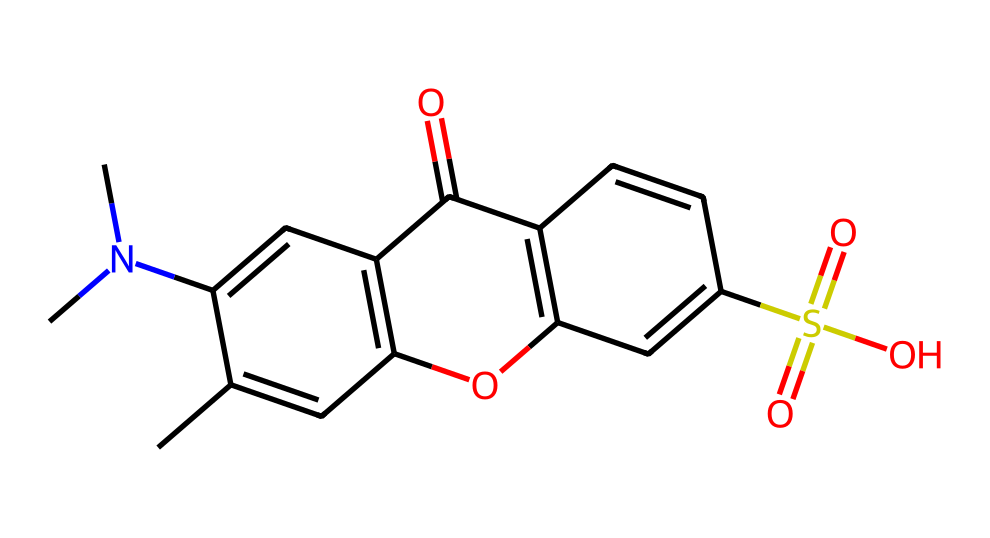What is the primary functional group present in this chemical? The chemical structure contains a sulfonic acid group (S(=O)(=O)O) indicated by the sulfur atom bonded to oxygen atoms and a hydroxyl group.
Answer: sulfonic acid How many nitrogen atoms are present in this chemical? Counting the nitrogen atoms in the structure reveals there is one nitrogen atom attached to an aliphatic chain (N(C)).
Answer: one What type of chemical structure does this compound represent? The presence of a sulfonic acid group alongside various aromatic rings indicates that this compound is a fluorescent dye, specifically used in photoreactive applications in sportswear.
Answer: fluorescent dye Which element is responsible for the photoreactive properties of this chemical? The presence of the conjugated system of aromatic rings along with the functional groups, especially the sulfonic acid, contributes to the ability of this compound to absorb light and become reactive under radiation.
Answer: conjugated system What is the total number of carbon atoms in this compound? By carefully counting the carbon atoms in the structure, we find there are a total of 16 carbon atoms in the compound.
Answer: sixteen What role does the sulfonic acid group play in this chemical? The sulfonic acid group enhances the solubility of the dye in water, improving its performance in textiles while ensuring it remains effective under varying conditions.
Answer: enhances solubility 